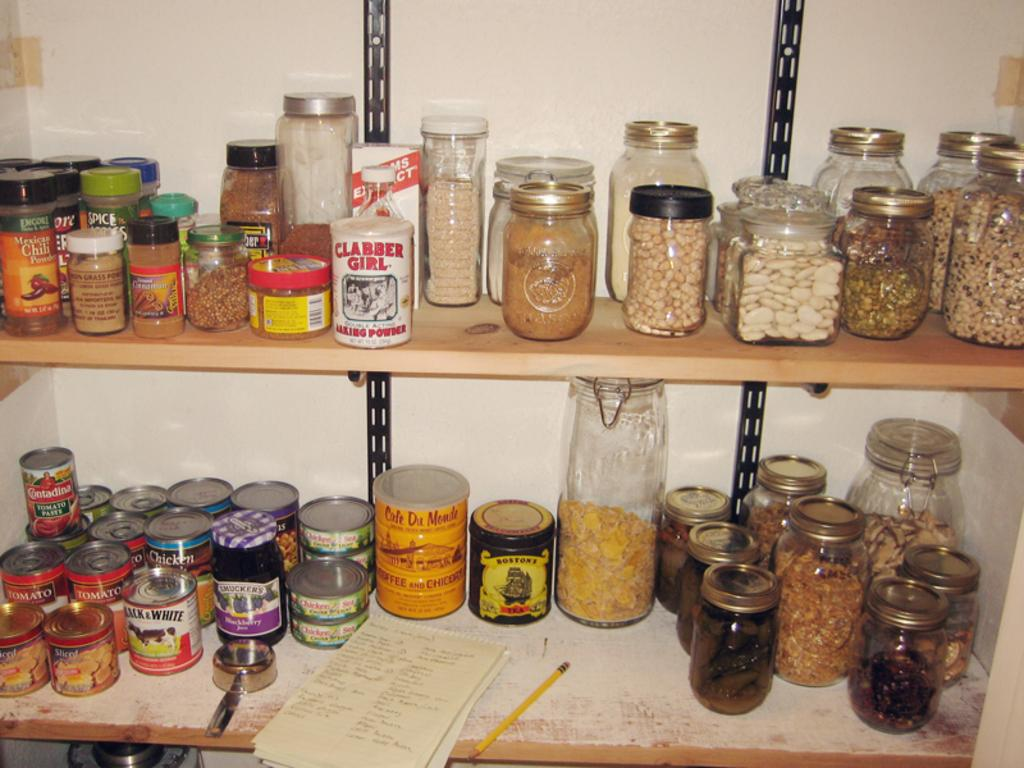What can be seen in the image that contains objects? There are jars in the image that contain objects. Where are the jars located? The jars are placed on wooden shelves. What type of behavior can be observed in the jars in the image? There is no behavior to observe in the jars, as they are inanimate objects. 